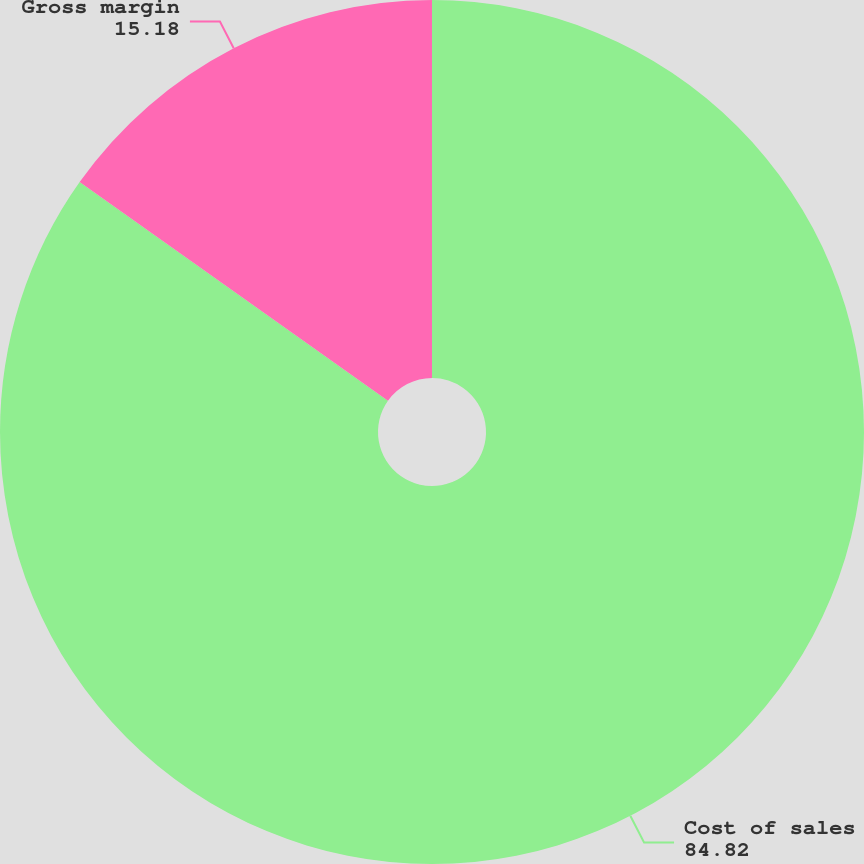Convert chart. <chart><loc_0><loc_0><loc_500><loc_500><pie_chart><fcel>Cost of sales<fcel>Gross margin<nl><fcel>84.82%<fcel>15.18%<nl></chart> 